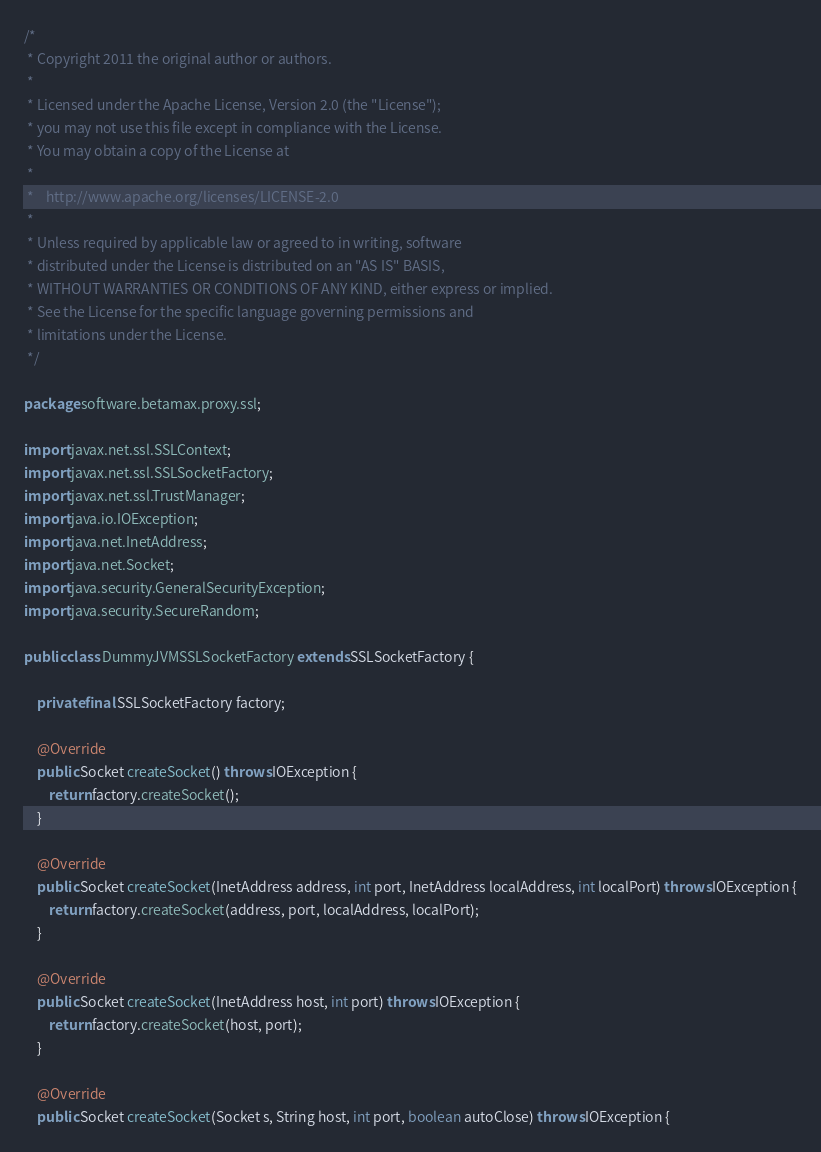<code> <loc_0><loc_0><loc_500><loc_500><_Java_>/*
 * Copyright 2011 the original author or authors.
 *
 * Licensed under the Apache License, Version 2.0 (the "License");
 * you may not use this file except in compliance with the License.
 * You may obtain a copy of the License at
 *
 *    http://www.apache.org/licenses/LICENSE-2.0
 *
 * Unless required by applicable law or agreed to in writing, software
 * distributed under the License is distributed on an "AS IS" BASIS,
 * WITHOUT WARRANTIES OR CONDITIONS OF ANY KIND, either express or implied.
 * See the License for the specific language governing permissions and
 * limitations under the License.
 */

package software.betamax.proxy.ssl;

import javax.net.ssl.SSLContext;
import javax.net.ssl.SSLSocketFactory;
import javax.net.ssl.TrustManager;
import java.io.IOException;
import java.net.InetAddress;
import java.net.Socket;
import java.security.GeneralSecurityException;
import java.security.SecureRandom;

public class DummyJVMSSLSocketFactory extends SSLSocketFactory {

    private final SSLSocketFactory factory;

    @Override
    public Socket createSocket() throws IOException {
        return factory.createSocket();
    }

    @Override
    public Socket createSocket(InetAddress address, int port, InetAddress localAddress, int localPort) throws IOException {
        return factory.createSocket(address, port, localAddress, localPort);
    }

    @Override
    public Socket createSocket(InetAddress host, int port) throws IOException {
        return factory.createSocket(host, port);
    }

    @Override
    public Socket createSocket(Socket s, String host, int port, boolean autoClose) throws IOException {</code> 